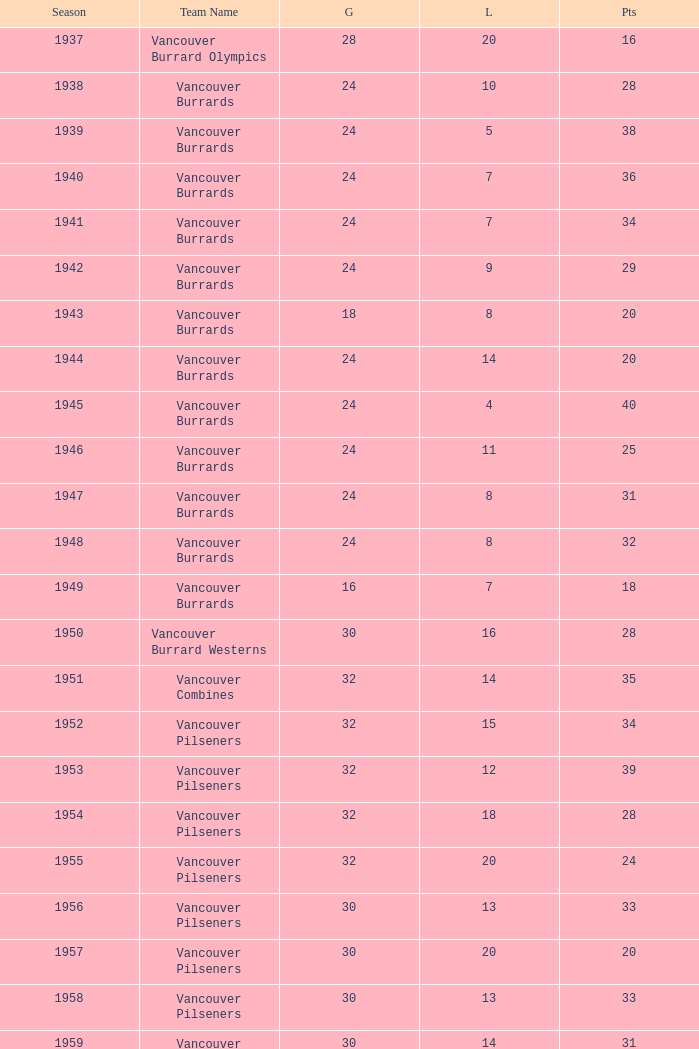What's the total number of points when the vancouver burrards have fewer than 9 losses and more than 24 games? 1.0. 